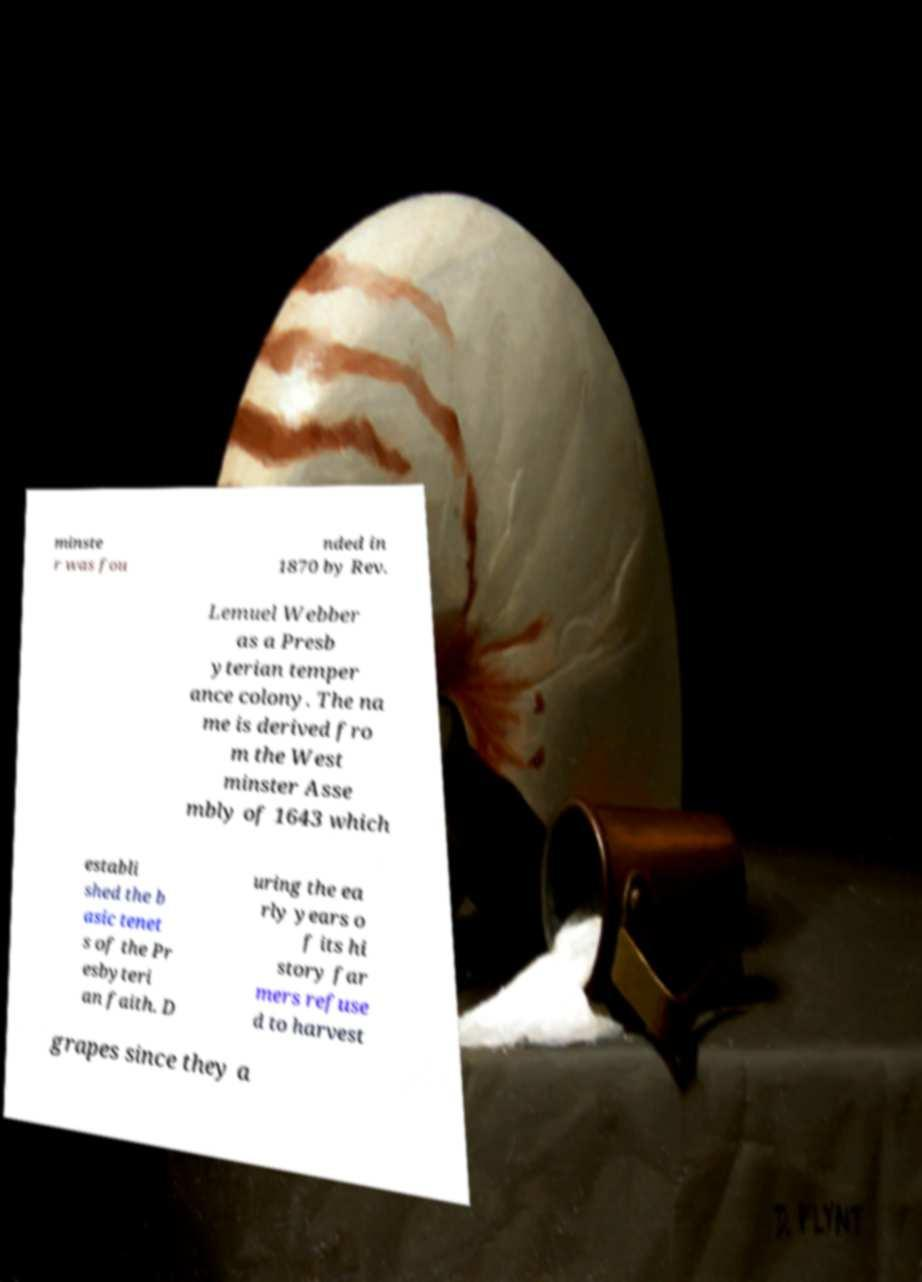Could you extract and type out the text from this image? minste r was fou nded in 1870 by Rev. Lemuel Webber as a Presb yterian temper ance colony. The na me is derived fro m the West minster Asse mbly of 1643 which establi shed the b asic tenet s of the Pr esbyteri an faith. D uring the ea rly years o f its hi story far mers refuse d to harvest grapes since they a 